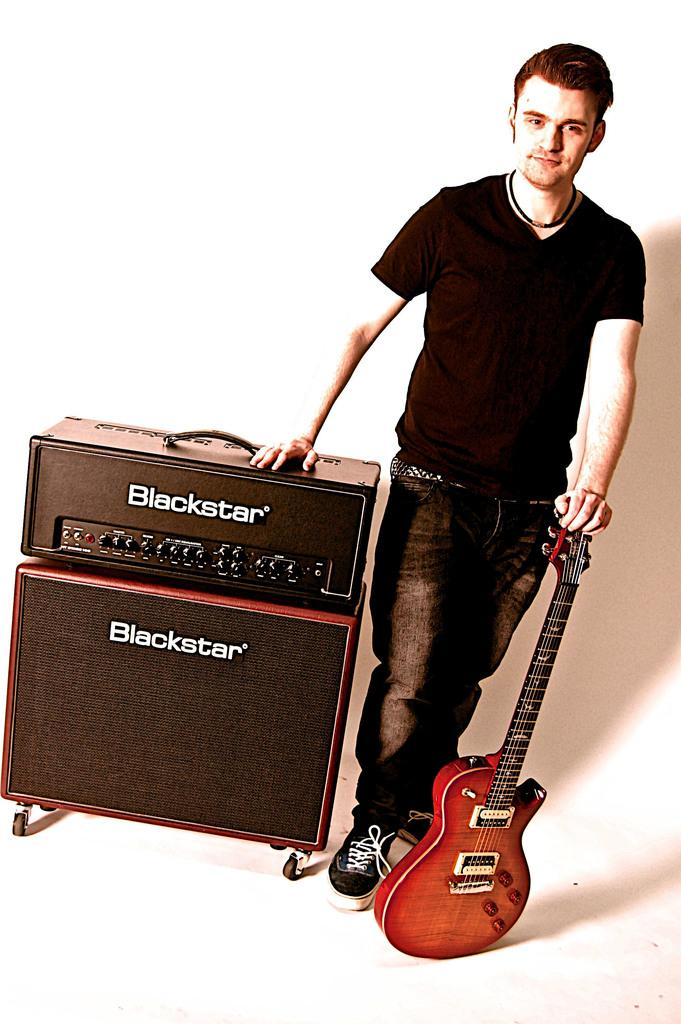What is the man in the image doing? The man is standing in the image. What is the man wearing? The man is wearing a black t-shirt and jeans. What object is the man touching with one of his hands? The man is resting his hand on a guitar. What is the man touching with his other hand? The man has his other hand on a box named "Blackstar". What type of art can be seen on the police officer's uniform in the image? There is no police officer or any art on a uniform present in the image. What type of thread is used to sew the man's t-shirt in the image? The type of thread used to sew the man's t-shirt is not visible or mentioned in the image. 